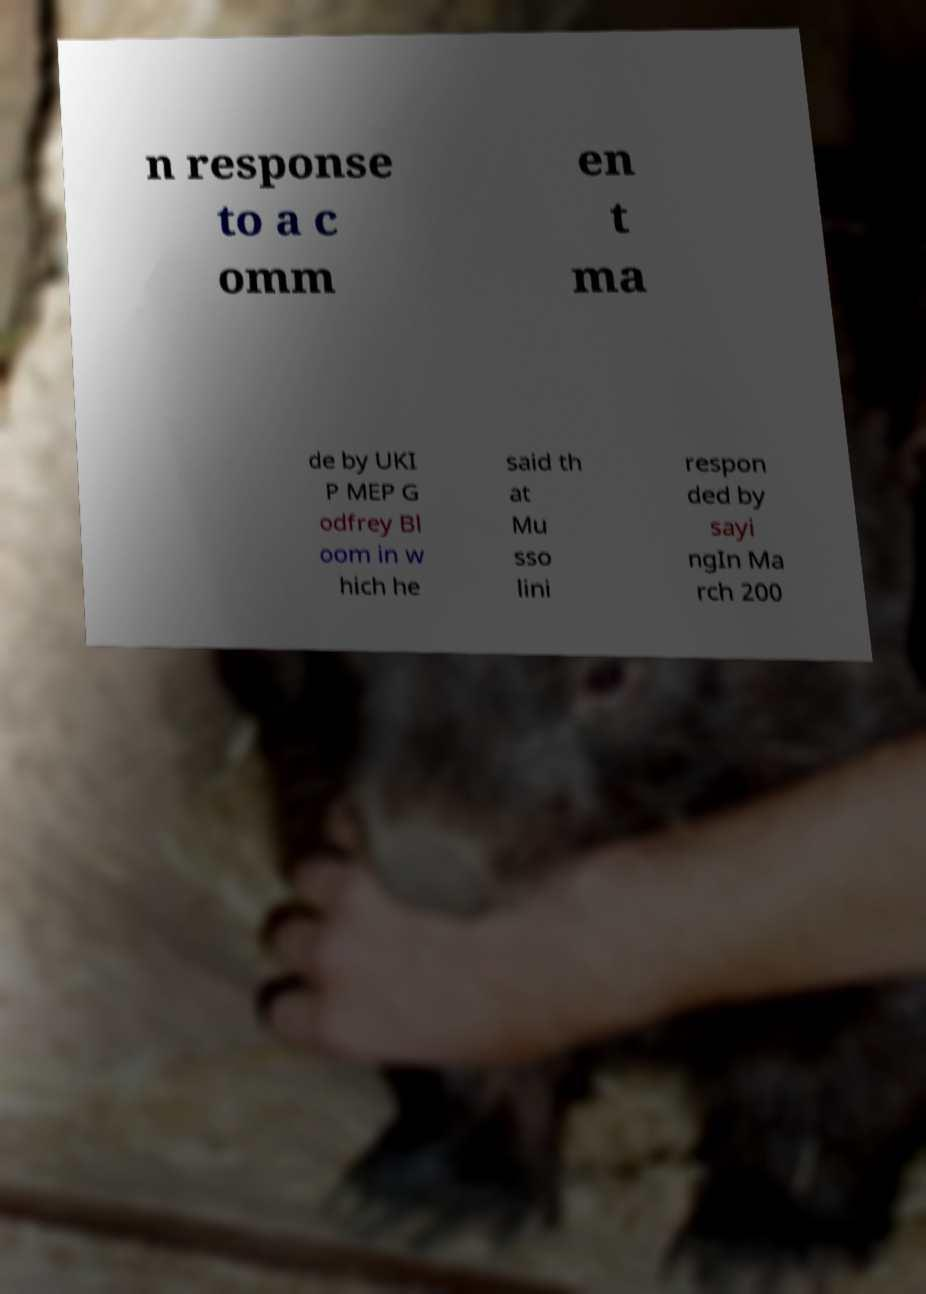Could you assist in decoding the text presented in this image and type it out clearly? n response to a c omm en t ma de by UKI P MEP G odfrey Bl oom in w hich he said th at Mu sso lini respon ded by sayi ngIn Ma rch 200 